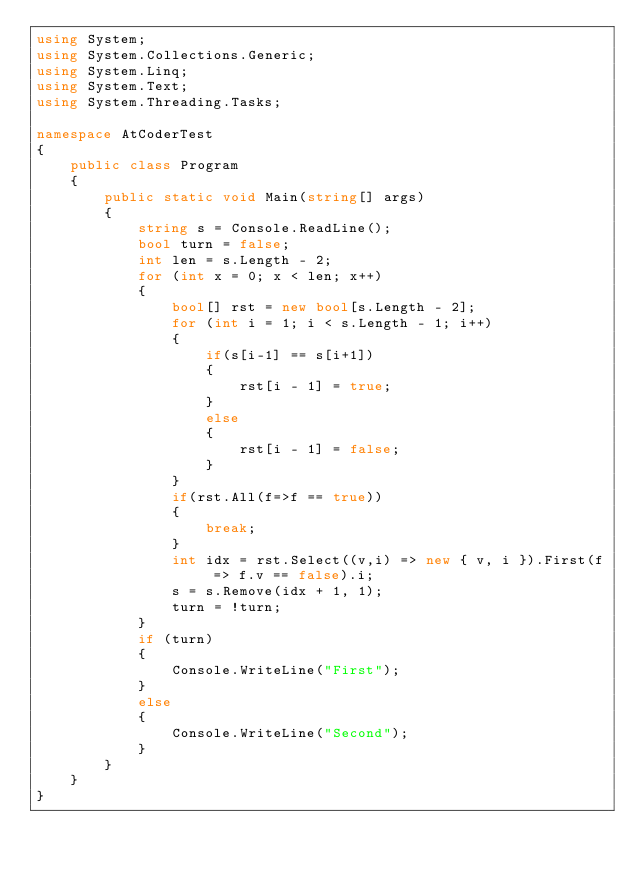<code> <loc_0><loc_0><loc_500><loc_500><_C#_>using System;
using System.Collections.Generic;
using System.Linq;
using System.Text;
using System.Threading.Tasks;

namespace AtCoderTest
{
    public class Program
    {
        public static void Main(string[] args)
        {
            string s = Console.ReadLine();
            bool turn = false;
            int len = s.Length - 2;
            for (int x = 0; x < len; x++)
            {
                bool[] rst = new bool[s.Length - 2];
                for (int i = 1; i < s.Length - 1; i++)
                {
                    if(s[i-1] == s[i+1])
                    {
                        rst[i - 1] = true;
                    }
                    else
                    {
                        rst[i - 1] = false;
                    }
                }
                if(rst.All(f=>f == true))
                {
                    break;
                }
                int idx = rst.Select((v,i) => new { v, i }).First(f => f.v == false).i;
                s = s.Remove(idx + 1, 1);
                turn = !turn;
            }
            if (turn)
            {
                Console.WriteLine("First");
            }
            else
            {
                Console.WriteLine("Second");
            }
        }
    }
}
</code> 